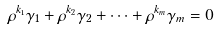Convert formula to latex. <formula><loc_0><loc_0><loc_500><loc_500>\rho ^ { k _ { 1 } } \gamma _ { 1 } + \rho ^ { k _ { 2 } } \gamma _ { 2 } + \cdots + \rho ^ { k _ { m } } \gamma _ { m } = 0</formula> 